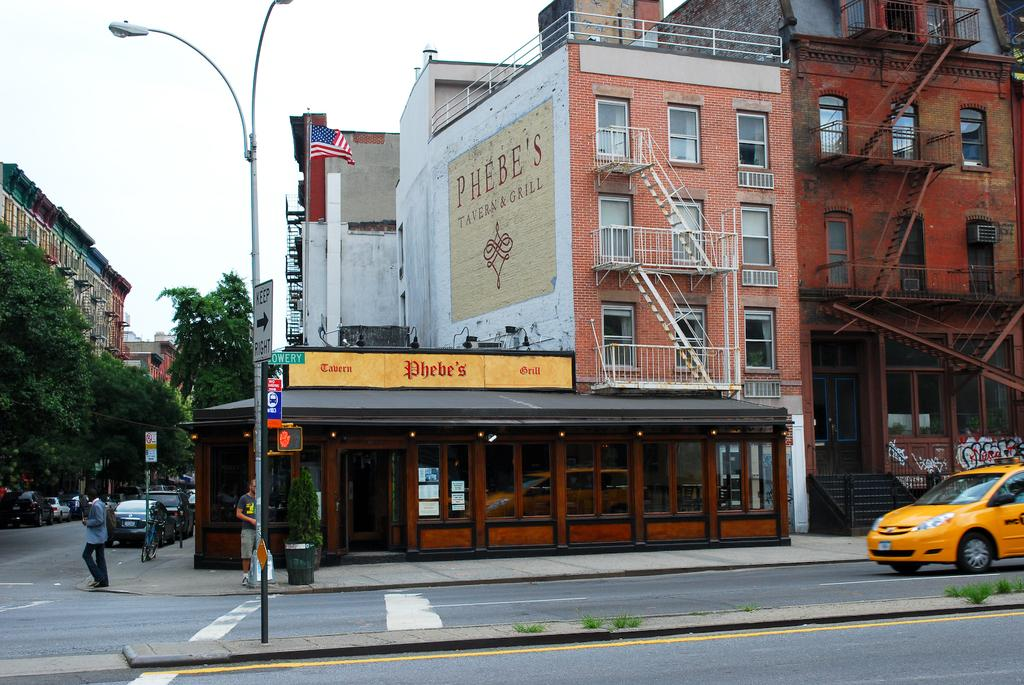Provide a one-sentence caption for the provided image. The street view of the Phebe's Tavern and Grill facade. 